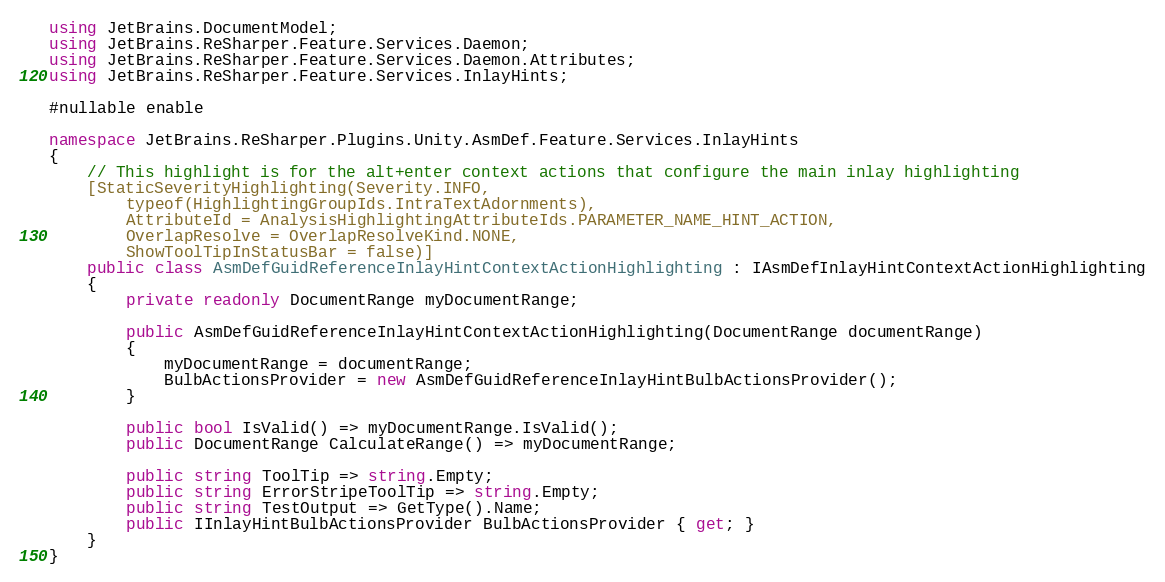<code> <loc_0><loc_0><loc_500><loc_500><_C#_>using JetBrains.DocumentModel;
using JetBrains.ReSharper.Feature.Services.Daemon;
using JetBrains.ReSharper.Feature.Services.Daemon.Attributes;
using JetBrains.ReSharper.Feature.Services.InlayHints;

#nullable enable

namespace JetBrains.ReSharper.Plugins.Unity.AsmDef.Feature.Services.InlayHints
{
    // This highlight is for the alt+enter context actions that configure the main inlay highlighting
    [StaticSeverityHighlighting(Severity.INFO,
        typeof(HighlightingGroupIds.IntraTextAdornments),
        AttributeId = AnalysisHighlightingAttributeIds.PARAMETER_NAME_HINT_ACTION,
        OverlapResolve = OverlapResolveKind.NONE,
        ShowToolTipInStatusBar = false)]
    public class AsmDefGuidReferenceInlayHintContextActionHighlighting : IAsmDefInlayHintContextActionHighlighting
    {
        private readonly DocumentRange myDocumentRange;

        public AsmDefGuidReferenceInlayHintContextActionHighlighting(DocumentRange documentRange)
        {
            myDocumentRange = documentRange;
            BulbActionsProvider = new AsmDefGuidReferenceInlayHintBulbActionsProvider();
        }

        public bool IsValid() => myDocumentRange.IsValid();
        public DocumentRange CalculateRange() => myDocumentRange;

        public string ToolTip => string.Empty;
        public string ErrorStripeToolTip => string.Empty;
        public string TestOutput => GetType().Name;
        public IInlayHintBulbActionsProvider BulbActionsProvider { get; }
    }
}</code> 